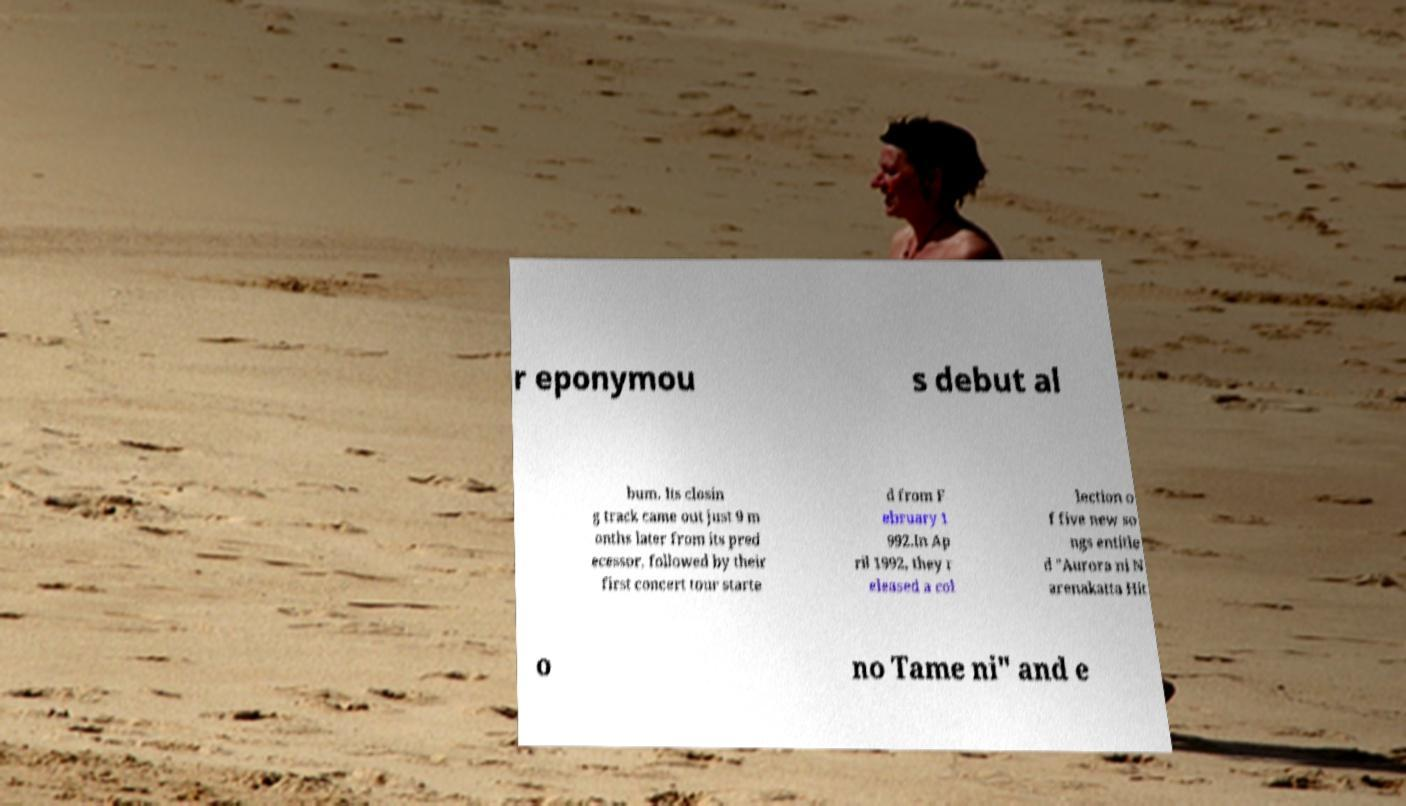Please identify and transcribe the text found in this image. r eponymou s debut al bum. Its closin g track came out just 9 m onths later from its pred ecessor, followed by their first concert tour starte d from F ebruary 1 992.In Ap ril 1992, they r eleased a col lection o f five new so ngs entitle d "Aurora ni N arenakatta Hit o no Tame ni" and e 